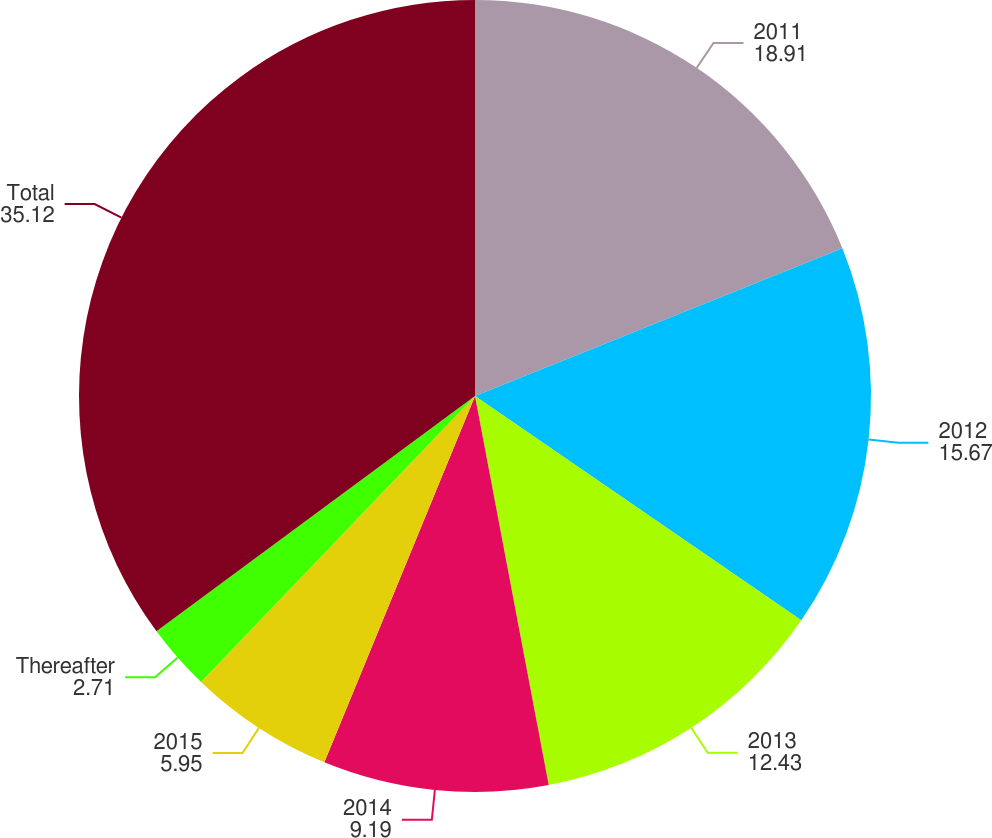Convert chart to OTSL. <chart><loc_0><loc_0><loc_500><loc_500><pie_chart><fcel>2011<fcel>2012<fcel>2013<fcel>2014<fcel>2015<fcel>Thereafter<fcel>Total<nl><fcel>18.91%<fcel>15.67%<fcel>12.43%<fcel>9.19%<fcel>5.95%<fcel>2.71%<fcel>35.12%<nl></chart> 